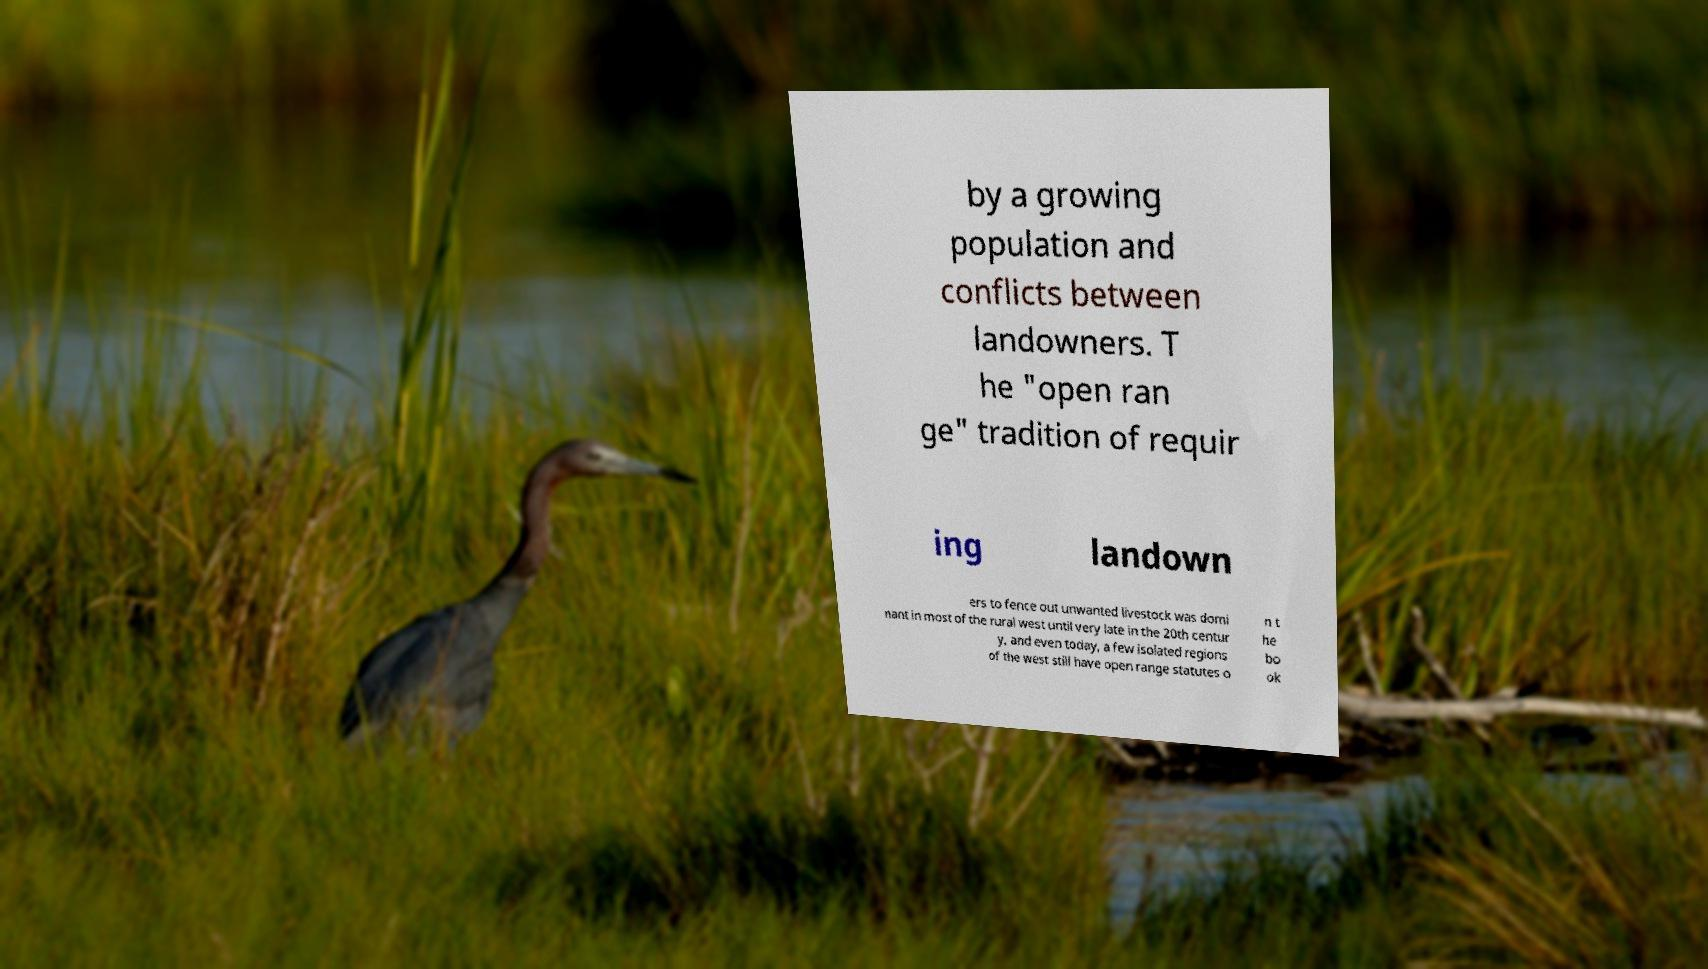Could you extract and type out the text from this image? by a growing population and conflicts between landowners. T he "open ran ge" tradition of requir ing landown ers to fence out unwanted livestock was domi nant in most of the rural west until very late in the 20th centur y, and even today, a few isolated regions of the west still have open range statutes o n t he bo ok 